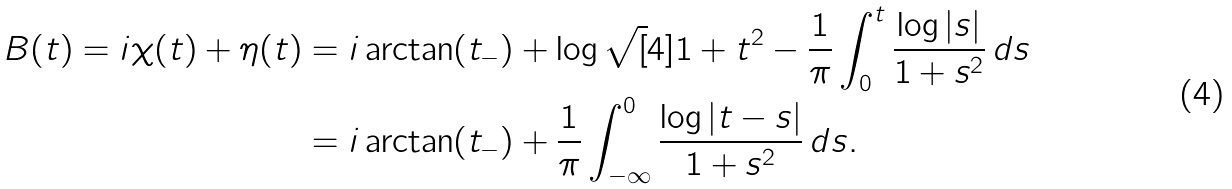Convert formula to latex. <formula><loc_0><loc_0><loc_500><loc_500>B ( t ) = i \chi ( t ) + \eta ( t ) & = i \arctan ( t _ { - } ) + \log \sqrt { [ } 4 ] { 1 + t ^ { 2 } } - \frac { 1 } { \pi } \int _ { 0 } ^ { t } \frac { \log | s | } { 1 + s ^ { 2 } } \, d s \\ & = i \arctan ( t _ { - } ) + \frac { 1 } { \pi } \int _ { - \infty } ^ { 0 } \frac { \log | t - s | } { 1 + s ^ { 2 } } \, d s .</formula> 